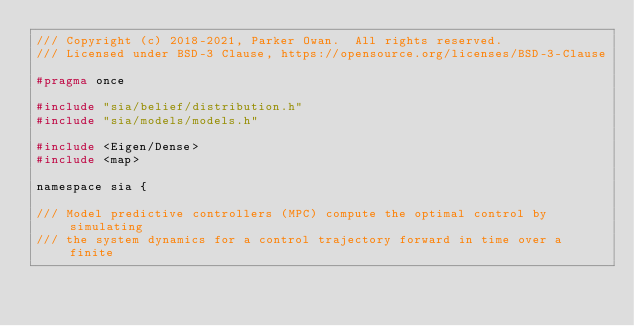<code> <loc_0><loc_0><loc_500><loc_500><_C_>/// Copyright (c) 2018-2021, Parker Owan.  All rights reserved.
/// Licensed under BSD-3 Clause, https://opensource.org/licenses/BSD-3-Clause

#pragma once

#include "sia/belief/distribution.h"
#include "sia/models/models.h"

#include <Eigen/Dense>
#include <map>

namespace sia {

/// Model predictive controllers (MPC) compute the optimal control by simulating
/// the system dynamics for a control trajectory forward in time over a finite</code> 